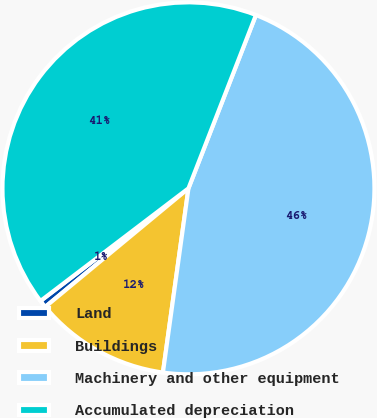Convert chart to OTSL. <chart><loc_0><loc_0><loc_500><loc_500><pie_chart><fcel>Land<fcel>Buildings<fcel>Machinery and other equipment<fcel>Accumulated depreciation<nl><fcel>0.65%<fcel>11.8%<fcel>46.28%<fcel>41.26%<nl></chart> 